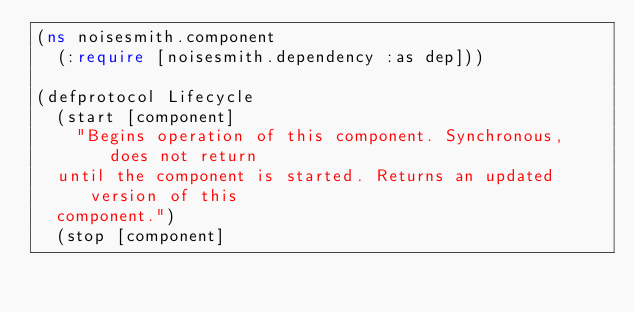<code> <loc_0><loc_0><loc_500><loc_500><_Clojure_>(ns noisesmith.component
  (:require [noisesmith.dependency :as dep]))

(defprotocol Lifecycle
  (start [component]
    "Begins operation of this component. Synchronous, does not return
  until the component is started. Returns an updated version of this
  component.")
  (stop [component]</code> 